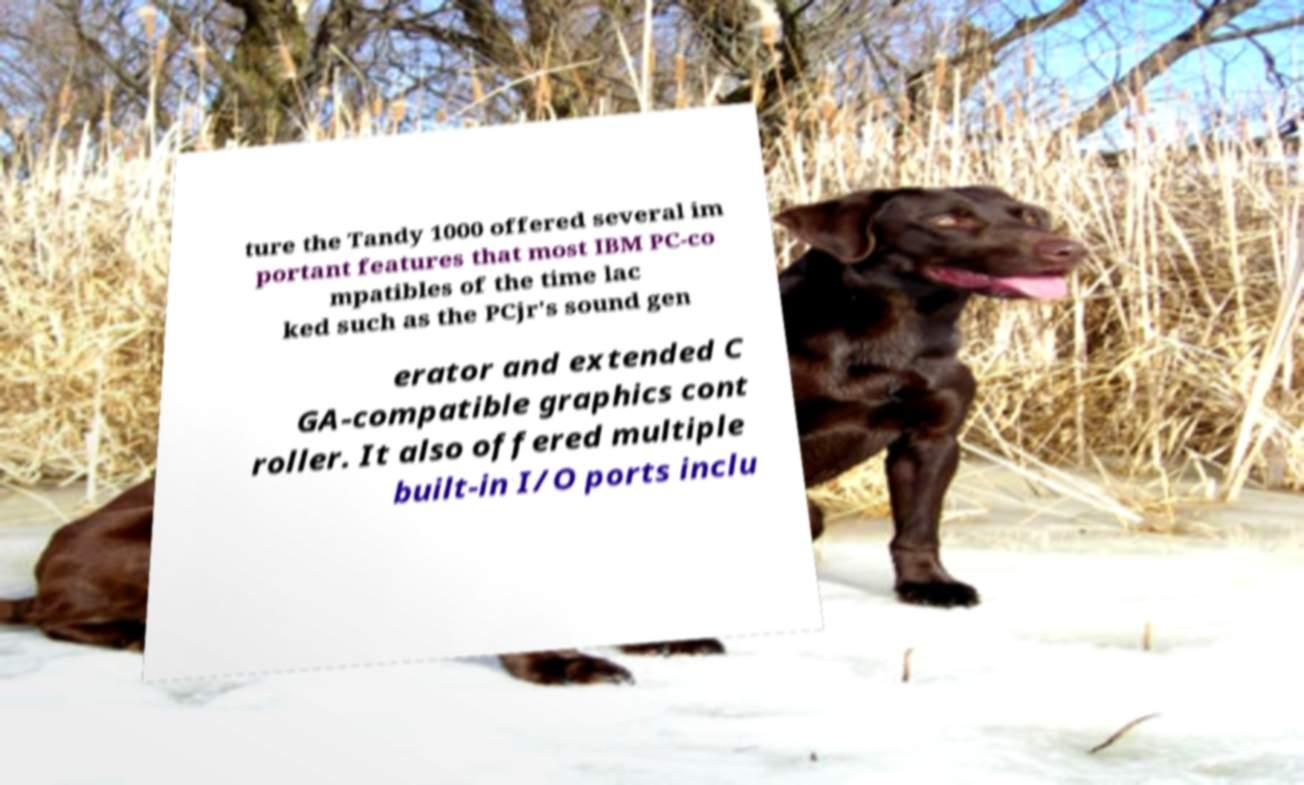For documentation purposes, I need the text within this image transcribed. Could you provide that? ture the Tandy 1000 offered several im portant features that most IBM PC-co mpatibles of the time lac ked such as the PCjr's sound gen erator and extended C GA-compatible graphics cont roller. It also offered multiple built-in I/O ports inclu 